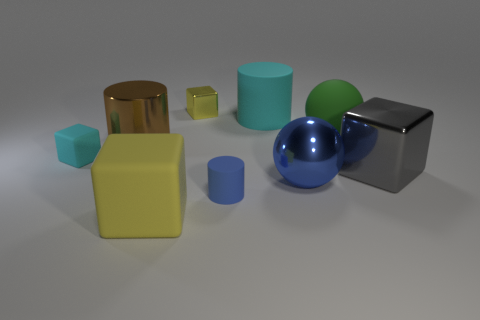Add 1 big green matte balls. How many objects exist? 10 Subtract all blocks. How many objects are left? 5 Add 5 big green rubber spheres. How many big green rubber spheres are left? 6 Add 9 blue rubber things. How many blue rubber things exist? 10 Subtract 0 cyan spheres. How many objects are left? 9 Subtract all big yellow matte cylinders. Subtract all small blocks. How many objects are left? 7 